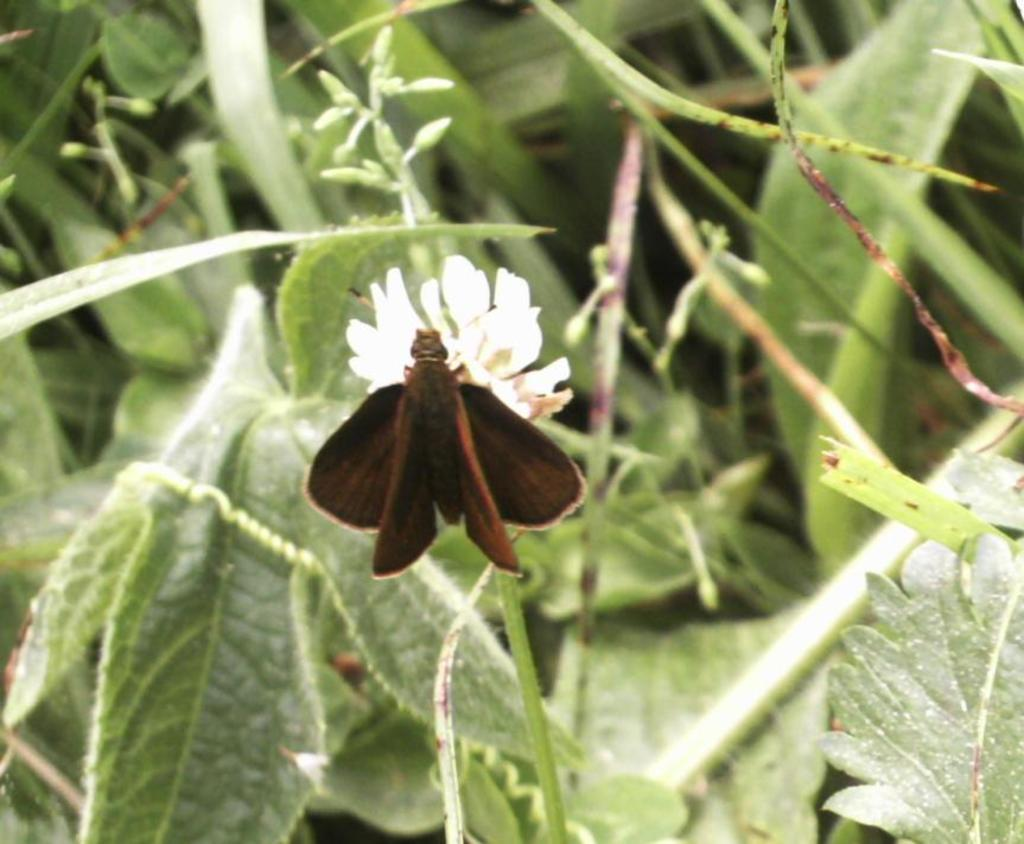What is on the flower in the image? There is an insect on a flower in the image. What else can be seen in the image besides the insect and flower? Leaves and stems are visible in the image. What type of bread is being used as a vegetable in the image? There is no bread or vegetable present in the image; it features an insect on a flower with leaves and stems. 